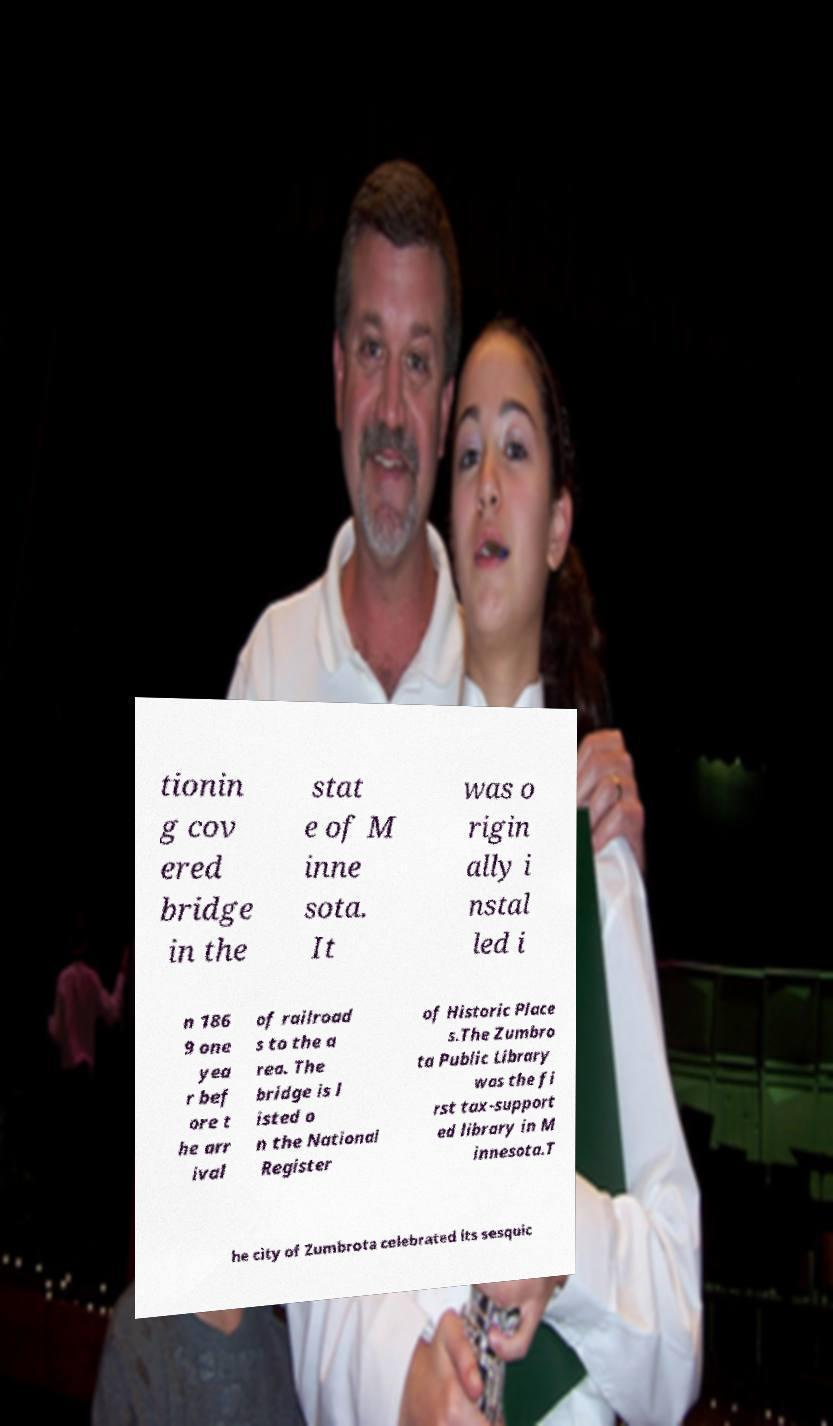Can you accurately transcribe the text from the provided image for me? tionin g cov ered bridge in the stat e of M inne sota. It was o rigin ally i nstal led i n 186 9 one yea r bef ore t he arr ival of railroad s to the a rea. The bridge is l isted o n the National Register of Historic Place s.The Zumbro ta Public Library was the fi rst tax-support ed library in M innesota.T he city of Zumbrota celebrated its sesquic 